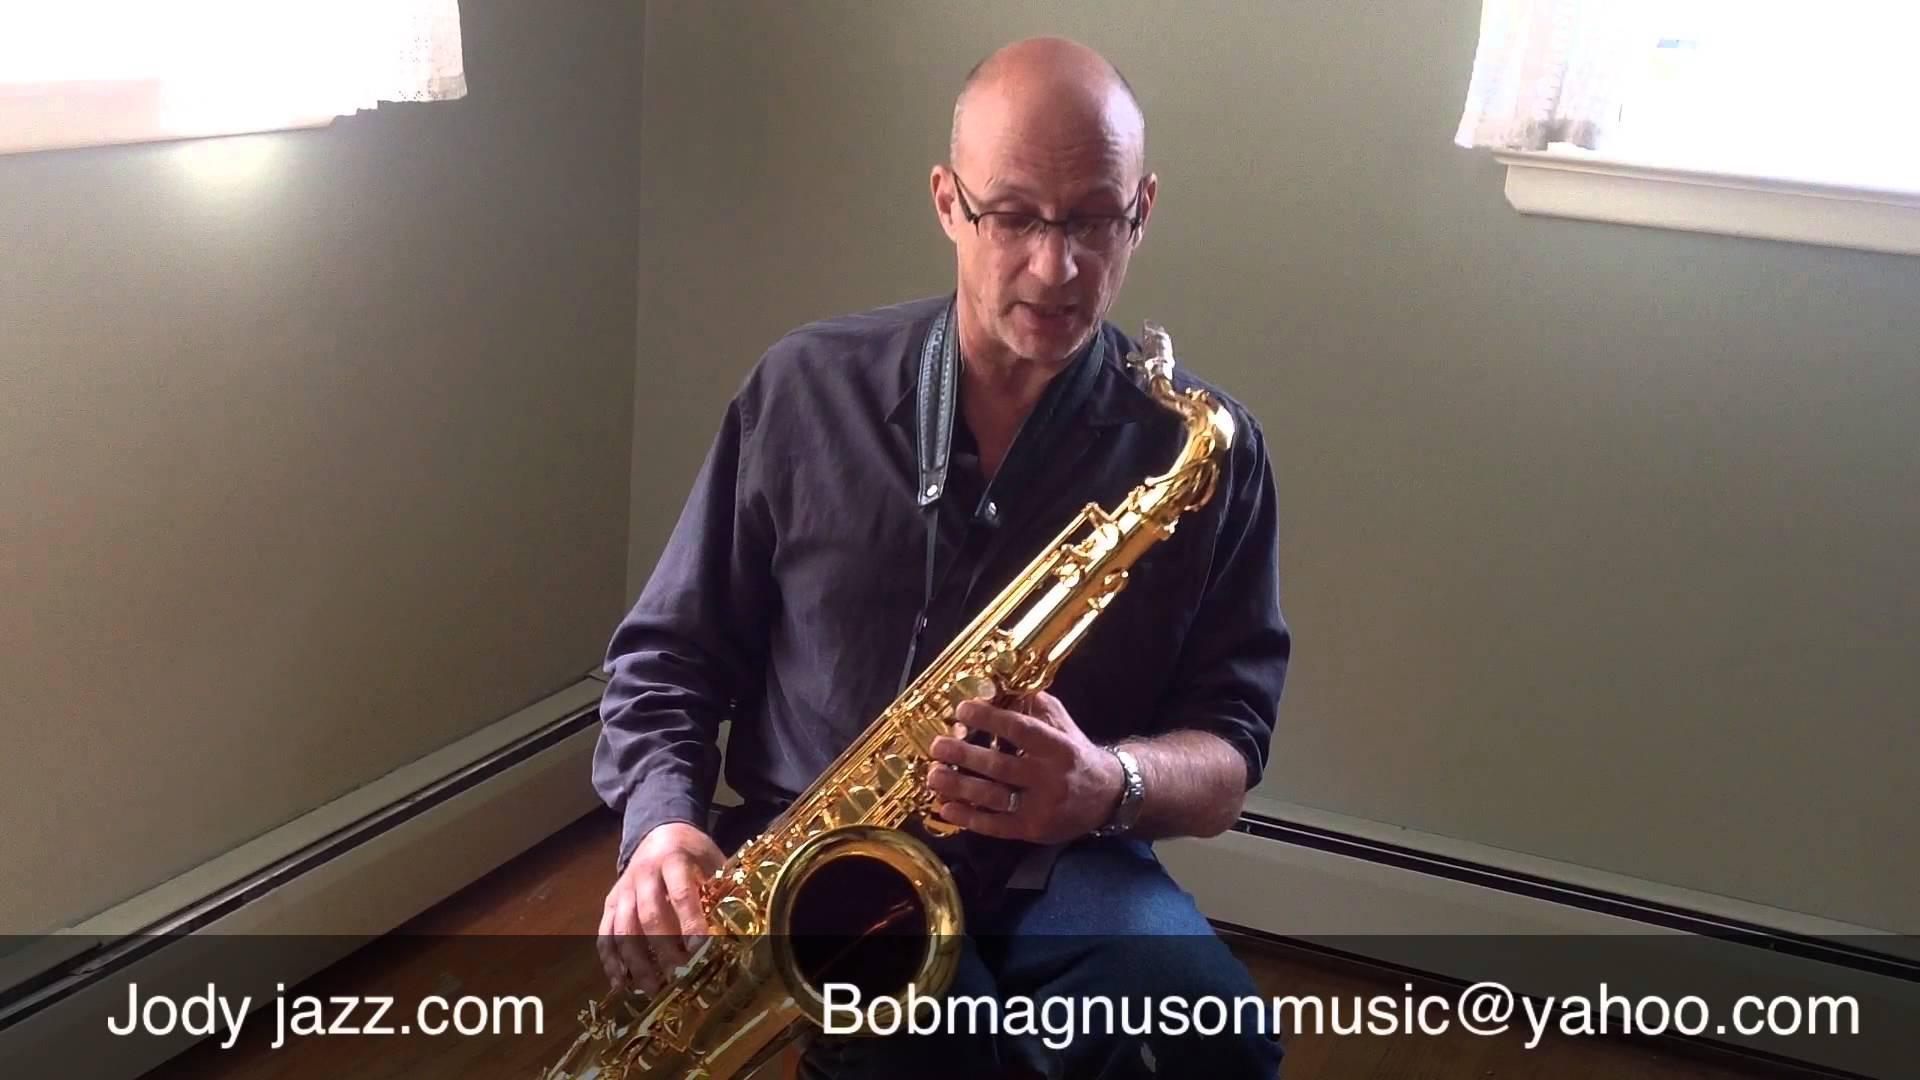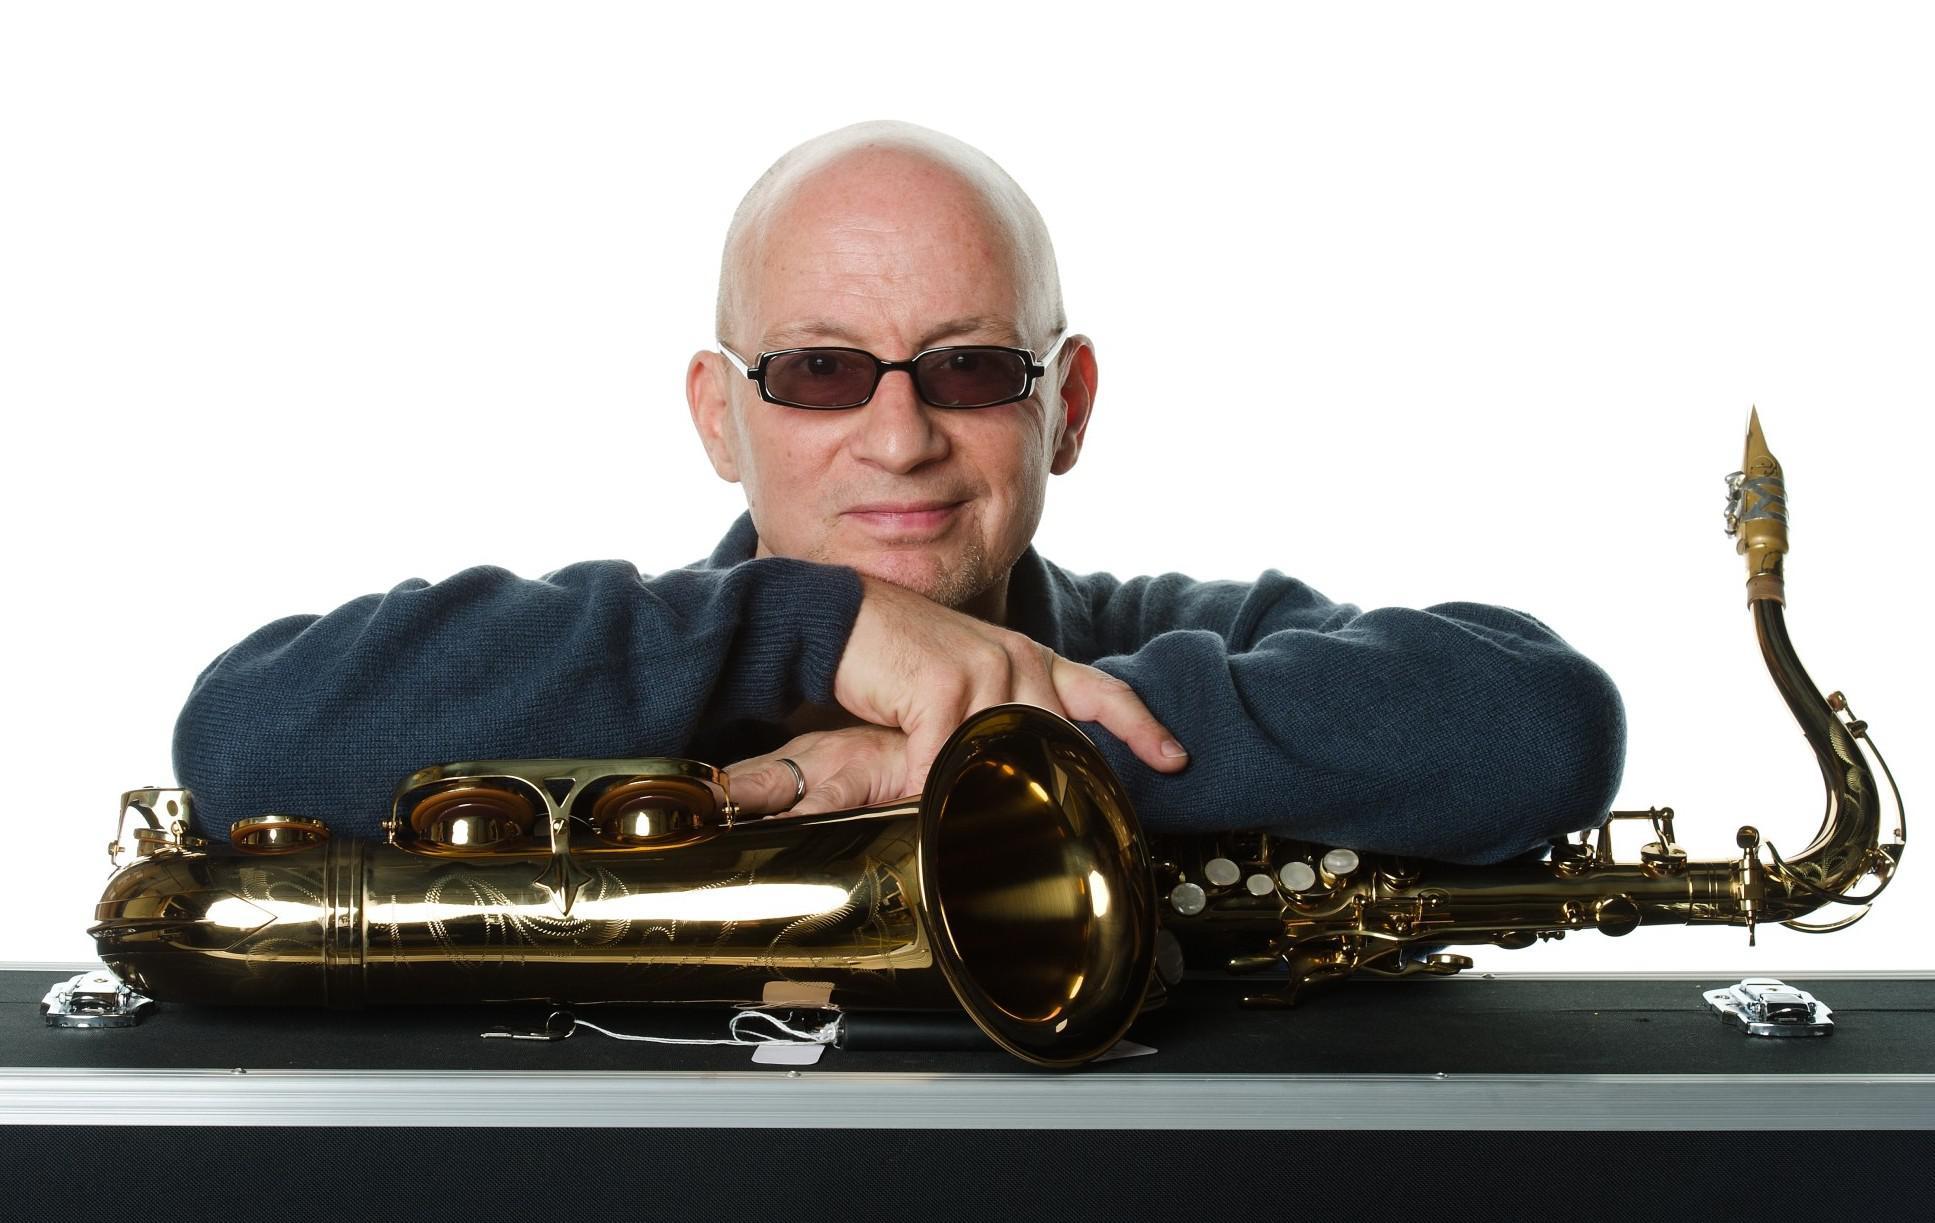The first image is the image on the left, the second image is the image on the right. Evaluate the accuracy of this statement regarding the images: "Each image shows a man with the mouthpiece of a brass-colored saxophone in his mouth.". Is it true? Answer yes or no. No. The first image is the image on the left, the second image is the image on the right. For the images shown, is this caption "The man is playing the alto sax and has it to his mouth in both of the images." true? Answer yes or no. No. 